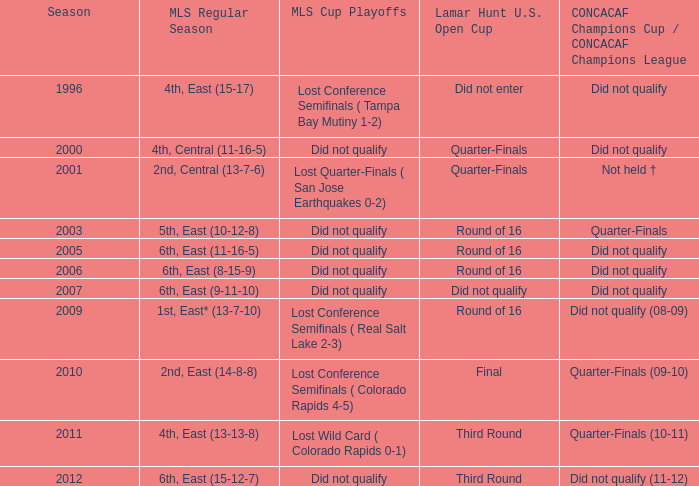Could you parse the entire table? {'header': ['Season', 'MLS Regular Season', 'MLS Cup Playoffs', 'Lamar Hunt U.S. Open Cup', 'CONCACAF Champions Cup / CONCACAF Champions League'], 'rows': [['1996', '4th, East (15-17)', 'Lost Conference Semifinals ( Tampa Bay Mutiny 1-2)', 'Did not enter', 'Did not qualify'], ['2000', '4th, Central (11-16-5)', 'Did not qualify', 'Quarter-Finals', 'Did not qualify'], ['2001', '2nd, Central (13-7-6)', 'Lost Quarter-Finals ( San Jose Earthquakes 0-2)', 'Quarter-Finals', 'Not held †'], ['2003', '5th, East (10-12-8)', 'Did not qualify', 'Round of 16', 'Quarter-Finals'], ['2005', '6th, East (11-16-5)', 'Did not qualify', 'Round of 16', 'Did not qualify'], ['2006', '6th, East (8-15-9)', 'Did not qualify', 'Round of 16', 'Did not qualify'], ['2007', '6th, East (9-11-10)', 'Did not qualify', 'Did not qualify', 'Did not qualify'], ['2009', '1st, East* (13-7-10)', 'Lost Conference Semifinals ( Real Salt Lake 2-3)', 'Round of 16', 'Did not qualify (08-09)'], ['2010', '2nd, East (14-8-8)', 'Lost Conference Semifinals ( Colorado Rapids 4-5)', 'Final', 'Quarter-Finals (09-10)'], ['2011', '4th, East (13-13-8)', 'Lost Wild Card ( Colorado Rapids 0-1)', 'Third Round', 'Quarter-Finals (10-11)'], ['2012', '6th, East (15-12-7)', 'Did not qualify', 'Third Round', 'Did not qualify (11-12)']]} For the season when the mls regular season ranked 5th in the east (10-12-8), how many entries exist? 1.0. 